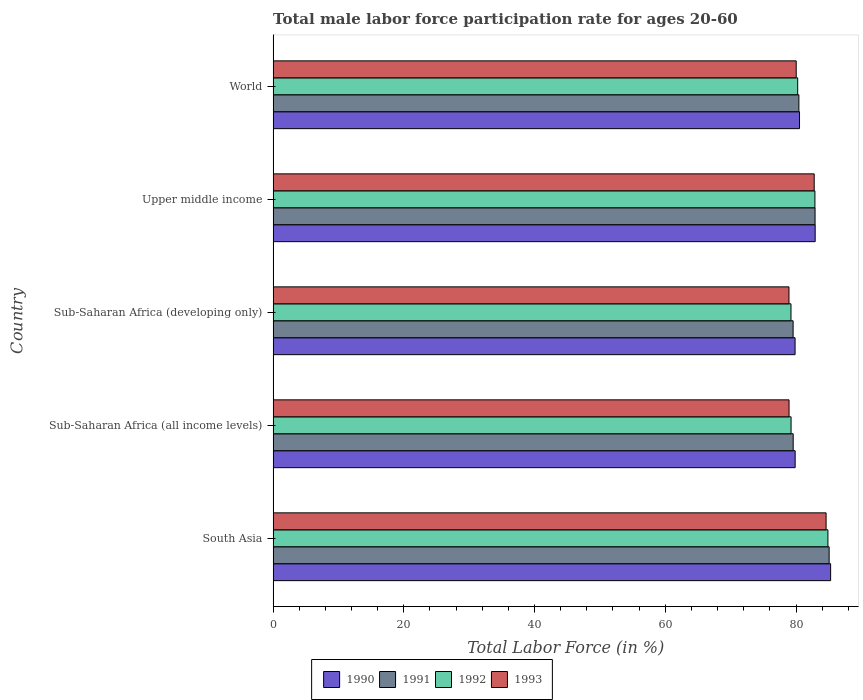Are the number of bars per tick equal to the number of legend labels?
Ensure brevity in your answer.  Yes. Are the number of bars on each tick of the Y-axis equal?
Make the answer very short. Yes. How many bars are there on the 1st tick from the top?
Ensure brevity in your answer.  4. What is the label of the 2nd group of bars from the top?
Keep it short and to the point. Upper middle income. In how many cases, is the number of bars for a given country not equal to the number of legend labels?
Offer a terse response. 0. What is the male labor force participation rate in 1990 in World?
Provide a short and direct response. 80.54. Across all countries, what is the maximum male labor force participation rate in 1992?
Provide a short and direct response. 84.88. Across all countries, what is the minimum male labor force participation rate in 1990?
Keep it short and to the point. 79.86. In which country was the male labor force participation rate in 1991 minimum?
Your answer should be compact. Sub-Saharan Africa (developing only). What is the total male labor force participation rate in 1991 in the graph?
Your answer should be very brief. 407.56. What is the difference between the male labor force participation rate in 1992 in Sub-Saharan Africa (all income levels) and that in Upper middle income?
Give a very brief answer. -3.65. What is the difference between the male labor force participation rate in 1993 in World and the male labor force participation rate in 1992 in Upper middle income?
Give a very brief answer. -2.86. What is the average male labor force participation rate in 1991 per country?
Ensure brevity in your answer.  81.51. What is the difference between the male labor force participation rate in 1990 and male labor force participation rate in 1993 in World?
Provide a short and direct response. 0.51. In how many countries, is the male labor force participation rate in 1992 greater than 24 %?
Offer a terse response. 5. What is the ratio of the male labor force participation rate in 1992 in South Asia to that in Sub-Saharan Africa (all income levels)?
Your response must be concise. 1.07. Is the male labor force participation rate in 1993 in Sub-Saharan Africa (developing only) less than that in World?
Give a very brief answer. Yes. What is the difference between the highest and the second highest male labor force participation rate in 1990?
Provide a short and direct response. 2.36. What is the difference between the highest and the lowest male labor force participation rate in 1992?
Keep it short and to the point. 5.65. In how many countries, is the male labor force participation rate in 1992 greater than the average male labor force participation rate in 1992 taken over all countries?
Give a very brief answer. 2. Is it the case that in every country, the sum of the male labor force participation rate in 1991 and male labor force participation rate in 1992 is greater than the sum of male labor force participation rate in 1990 and male labor force participation rate in 1993?
Your answer should be very brief. No. What does the 1st bar from the top in Sub-Saharan Africa (developing only) represents?
Your answer should be very brief. 1993. How many bars are there?
Make the answer very short. 20. What is the difference between two consecutive major ticks on the X-axis?
Your response must be concise. 20. Are the values on the major ticks of X-axis written in scientific E-notation?
Offer a very short reply. No. Does the graph contain grids?
Keep it short and to the point. No. Where does the legend appear in the graph?
Offer a very short reply. Bottom center. How many legend labels are there?
Your response must be concise. 4. What is the title of the graph?
Your response must be concise. Total male labor force participation rate for ages 20-60. Does "1979" appear as one of the legend labels in the graph?
Offer a terse response. No. What is the Total Labor Force (in %) of 1990 in South Asia?
Provide a succinct answer. 85.3. What is the Total Labor Force (in %) in 1991 in South Asia?
Make the answer very short. 85.07. What is the Total Labor Force (in %) in 1992 in South Asia?
Your response must be concise. 84.88. What is the Total Labor Force (in %) in 1993 in South Asia?
Your answer should be compact. 84.6. What is the Total Labor Force (in %) in 1990 in Sub-Saharan Africa (all income levels)?
Make the answer very short. 79.87. What is the Total Labor Force (in %) of 1991 in Sub-Saharan Africa (all income levels)?
Ensure brevity in your answer.  79.57. What is the Total Labor Force (in %) of 1992 in Sub-Saharan Africa (all income levels)?
Keep it short and to the point. 79.25. What is the Total Labor Force (in %) of 1993 in Sub-Saharan Africa (all income levels)?
Offer a terse response. 78.94. What is the Total Labor Force (in %) of 1990 in Sub-Saharan Africa (developing only)?
Give a very brief answer. 79.86. What is the Total Labor Force (in %) of 1991 in Sub-Saharan Africa (developing only)?
Your response must be concise. 79.56. What is the Total Labor Force (in %) in 1992 in Sub-Saharan Africa (developing only)?
Your response must be concise. 79.23. What is the Total Labor Force (in %) of 1993 in Sub-Saharan Africa (developing only)?
Keep it short and to the point. 78.93. What is the Total Labor Force (in %) of 1990 in Upper middle income?
Give a very brief answer. 82.93. What is the Total Labor Force (in %) of 1991 in Upper middle income?
Ensure brevity in your answer.  82.92. What is the Total Labor Force (in %) in 1992 in Upper middle income?
Offer a terse response. 82.89. What is the Total Labor Force (in %) of 1993 in Upper middle income?
Make the answer very short. 82.78. What is the Total Labor Force (in %) of 1990 in World?
Offer a terse response. 80.54. What is the Total Labor Force (in %) of 1991 in World?
Offer a very short reply. 80.44. What is the Total Labor Force (in %) in 1992 in World?
Keep it short and to the point. 80.26. What is the Total Labor Force (in %) in 1993 in World?
Keep it short and to the point. 80.03. Across all countries, what is the maximum Total Labor Force (in %) of 1990?
Ensure brevity in your answer.  85.3. Across all countries, what is the maximum Total Labor Force (in %) of 1991?
Your response must be concise. 85.07. Across all countries, what is the maximum Total Labor Force (in %) of 1992?
Your answer should be compact. 84.88. Across all countries, what is the maximum Total Labor Force (in %) in 1993?
Provide a short and direct response. 84.6. Across all countries, what is the minimum Total Labor Force (in %) of 1990?
Ensure brevity in your answer.  79.86. Across all countries, what is the minimum Total Labor Force (in %) in 1991?
Offer a very short reply. 79.56. Across all countries, what is the minimum Total Labor Force (in %) in 1992?
Offer a terse response. 79.23. Across all countries, what is the minimum Total Labor Force (in %) in 1993?
Make the answer very short. 78.93. What is the total Total Labor Force (in %) of 1990 in the graph?
Your response must be concise. 408.5. What is the total Total Labor Force (in %) in 1991 in the graph?
Make the answer very short. 407.56. What is the total Total Labor Force (in %) of 1992 in the graph?
Your answer should be compact. 406.52. What is the total Total Labor Force (in %) in 1993 in the graph?
Give a very brief answer. 405.28. What is the difference between the Total Labor Force (in %) in 1990 in South Asia and that in Sub-Saharan Africa (all income levels)?
Offer a terse response. 5.43. What is the difference between the Total Labor Force (in %) of 1991 in South Asia and that in Sub-Saharan Africa (all income levels)?
Your answer should be very brief. 5.5. What is the difference between the Total Labor Force (in %) in 1992 in South Asia and that in Sub-Saharan Africa (all income levels)?
Provide a succinct answer. 5.64. What is the difference between the Total Labor Force (in %) in 1993 in South Asia and that in Sub-Saharan Africa (all income levels)?
Provide a short and direct response. 5.67. What is the difference between the Total Labor Force (in %) in 1990 in South Asia and that in Sub-Saharan Africa (developing only)?
Your answer should be compact. 5.44. What is the difference between the Total Labor Force (in %) in 1991 in South Asia and that in Sub-Saharan Africa (developing only)?
Offer a terse response. 5.51. What is the difference between the Total Labor Force (in %) of 1992 in South Asia and that in Sub-Saharan Africa (developing only)?
Your response must be concise. 5.65. What is the difference between the Total Labor Force (in %) of 1993 in South Asia and that in Sub-Saharan Africa (developing only)?
Keep it short and to the point. 5.68. What is the difference between the Total Labor Force (in %) of 1990 in South Asia and that in Upper middle income?
Your answer should be compact. 2.36. What is the difference between the Total Labor Force (in %) in 1991 in South Asia and that in Upper middle income?
Give a very brief answer. 2.15. What is the difference between the Total Labor Force (in %) of 1992 in South Asia and that in Upper middle income?
Your answer should be very brief. 1.99. What is the difference between the Total Labor Force (in %) of 1993 in South Asia and that in Upper middle income?
Ensure brevity in your answer.  1.82. What is the difference between the Total Labor Force (in %) in 1990 in South Asia and that in World?
Provide a short and direct response. 4.76. What is the difference between the Total Labor Force (in %) of 1991 in South Asia and that in World?
Your response must be concise. 4.63. What is the difference between the Total Labor Force (in %) in 1992 in South Asia and that in World?
Provide a short and direct response. 4.63. What is the difference between the Total Labor Force (in %) of 1993 in South Asia and that in World?
Give a very brief answer. 4.57. What is the difference between the Total Labor Force (in %) in 1990 in Sub-Saharan Africa (all income levels) and that in Sub-Saharan Africa (developing only)?
Ensure brevity in your answer.  0.01. What is the difference between the Total Labor Force (in %) of 1991 in Sub-Saharan Africa (all income levels) and that in Sub-Saharan Africa (developing only)?
Keep it short and to the point. 0.01. What is the difference between the Total Labor Force (in %) in 1992 in Sub-Saharan Africa (all income levels) and that in Sub-Saharan Africa (developing only)?
Your answer should be compact. 0.01. What is the difference between the Total Labor Force (in %) in 1993 in Sub-Saharan Africa (all income levels) and that in Sub-Saharan Africa (developing only)?
Your answer should be very brief. 0.01. What is the difference between the Total Labor Force (in %) of 1990 in Sub-Saharan Africa (all income levels) and that in Upper middle income?
Give a very brief answer. -3.06. What is the difference between the Total Labor Force (in %) of 1991 in Sub-Saharan Africa (all income levels) and that in Upper middle income?
Your response must be concise. -3.35. What is the difference between the Total Labor Force (in %) of 1992 in Sub-Saharan Africa (all income levels) and that in Upper middle income?
Offer a very short reply. -3.65. What is the difference between the Total Labor Force (in %) of 1993 in Sub-Saharan Africa (all income levels) and that in Upper middle income?
Make the answer very short. -3.85. What is the difference between the Total Labor Force (in %) in 1990 in Sub-Saharan Africa (all income levels) and that in World?
Offer a terse response. -0.67. What is the difference between the Total Labor Force (in %) of 1991 in Sub-Saharan Africa (all income levels) and that in World?
Offer a terse response. -0.87. What is the difference between the Total Labor Force (in %) in 1992 in Sub-Saharan Africa (all income levels) and that in World?
Offer a terse response. -1.01. What is the difference between the Total Labor Force (in %) of 1993 in Sub-Saharan Africa (all income levels) and that in World?
Offer a very short reply. -1.09. What is the difference between the Total Labor Force (in %) in 1990 in Sub-Saharan Africa (developing only) and that in Upper middle income?
Your response must be concise. -3.07. What is the difference between the Total Labor Force (in %) in 1991 in Sub-Saharan Africa (developing only) and that in Upper middle income?
Offer a very short reply. -3.36. What is the difference between the Total Labor Force (in %) in 1992 in Sub-Saharan Africa (developing only) and that in Upper middle income?
Give a very brief answer. -3.66. What is the difference between the Total Labor Force (in %) in 1993 in Sub-Saharan Africa (developing only) and that in Upper middle income?
Your answer should be compact. -3.86. What is the difference between the Total Labor Force (in %) of 1990 in Sub-Saharan Africa (developing only) and that in World?
Ensure brevity in your answer.  -0.68. What is the difference between the Total Labor Force (in %) in 1991 in Sub-Saharan Africa (developing only) and that in World?
Your answer should be compact. -0.88. What is the difference between the Total Labor Force (in %) of 1992 in Sub-Saharan Africa (developing only) and that in World?
Offer a terse response. -1.02. What is the difference between the Total Labor Force (in %) of 1993 in Sub-Saharan Africa (developing only) and that in World?
Make the answer very short. -1.11. What is the difference between the Total Labor Force (in %) of 1990 in Upper middle income and that in World?
Provide a short and direct response. 2.4. What is the difference between the Total Labor Force (in %) of 1991 in Upper middle income and that in World?
Your answer should be compact. 2.48. What is the difference between the Total Labor Force (in %) of 1992 in Upper middle income and that in World?
Your answer should be compact. 2.64. What is the difference between the Total Labor Force (in %) in 1993 in Upper middle income and that in World?
Offer a terse response. 2.75. What is the difference between the Total Labor Force (in %) of 1990 in South Asia and the Total Labor Force (in %) of 1991 in Sub-Saharan Africa (all income levels)?
Offer a terse response. 5.73. What is the difference between the Total Labor Force (in %) of 1990 in South Asia and the Total Labor Force (in %) of 1992 in Sub-Saharan Africa (all income levels)?
Your answer should be very brief. 6.05. What is the difference between the Total Labor Force (in %) in 1990 in South Asia and the Total Labor Force (in %) in 1993 in Sub-Saharan Africa (all income levels)?
Your response must be concise. 6.36. What is the difference between the Total Labor Force (in %) in 1991 in South Asia and the Total Labor Force (in %) in 1992 in Sub-Saharan Africa (all income levels)?
Ensure brevity in your answer.  5.83. What is the difference between the Total Labor Force (in %) in 1991 in South Asia and the Total Labor Force (in %) in 1993 in Sub-Saharan Africa (all income levels)?
Keep it short and to the point. 6.13. What is the difference between the Total Labor Force (in %) of 1992 in South Asia and the Total Labor Force (in %) of 1993 in Sub-Saharan Africa (all income levels)?
Offer a terse response. 5.95. What is the difference between the Total Labor Force (in %) of 1990 in South Asia and the Total Labor Force (in %) of 1991 in Sub-Saharan Africa (developing only)?
Give a very brief answer. 5.74. What is the difference between the Total Labor Force (in %) in 1990 in South Asia and the Total Labor Force (in %) in 1992 in Sub-Saharan Africa (developing only)?
Provide a short and direct response. 6.06. What is the difference between the Total Labor Force (in %) in 1990 in South Asia and the Total Labor Force (in %) in 1993 in Sub-Saharan Africa (developing only)?
Your answer should be very brief. 6.37. What is the difference between the Total Labor Force (in %) in 1991 in South Asia and the Total Labor Force (in %) in 1992 in Sub-Saharan Africa (developing only)?
Give a very brief answer. 5.84. What is the difference between the Total Labor Force (in %) of 1991 in South Asia and the Total Labor Force (in %) of 1993 in Sub-Saharan Africa (developing only)?
Provide a succinct answer. 6.14. What is the difference between the Total Labor Force (in %) of 1992 in South Asia and the Total Labor Force (in %) of 1993 in Sub-Saharan Africa (developing only)?
Make the answer very short. 5.96. What is the difference between the Total Labor Force (in %) in 1990 in South Asia and the Total Labor Force (in %) in 1991 in Upper middle income?
Your response must be concise. 2.38. What is the difference between the Total Labor Force (in %) in 1990 in South Asia and the Total Labor Force (in %) in 1992 in Upper middle income?
Make the answer very short. 2.4. What is the difference between the Total Labor Force (in %) of 1990 in South Asia and the Total Labor Force (in %) of 1993 in Upper middle income?
Keep it short and to the point. 2.51. What is the difference between the Total Labor Force (in %) of 1991 in South Asia and the Total Labor Force (in %) of 1992 in Upper middle income?
Ensure brevity in your answer.  2.18. What is the difference between the Total Labor Force (in %) in 1991 in South Asia and the Total Labor Force (in %) in 1993 in Upper middle income?
Ensure brevity in your answer.  2.29. What is the difference between the Total Labor Force (in %) of 1992 in South Asia and the Total Labor Force (in %) of 1993 in Upper middle income?
Make the answer very short. 2.1. What is the difference between the Total Labor Force (in %) in 1990 in South Asia and the Total Labor Force (in %) in 1991 in World?
Your answer should be very brief. 4.86. What is the difference between the Total Labor Force (in %) in 1990 in South Asia and the Total Labor Force (in %) in 1992 in World?
Your response must be concise. 5.04. What is the difference between the Total Labor Force (in %) in 1990 in South Asia and the Total Labor Force (in %) in 1993 in World?
Your answer should be very brief. 5.27. What is the difference between the Total Labor Force (in %) in 1991 in South Asia and the Total Labor Force (in %) in 1992 in World?
Make the answer very short. 4.81. What is the difference between the Total Labor Force (in %) in 1991 in South Asia and the Total Labor Force (in %) in 1993 in World?
Provide a succinct answer. 5.04. What is the difference between the Total Labor Force (in %) of 1992 in South Asia and the Total Labor Force (in %) of 1993 in World?
Ensure brevity in your answer.  4.85. What is the difference between the Total Labor Force (in %) of 1990 in Sub-Saharan Africa (all income levels) and the Total Labor Force (in %) of 1991 in Sub-Saharan Africa (developing only)?
Your answer should be very brief. 0.31. What is the difference between the Total Labor Force (in %) in 1990 in Sub-Saharan Africa (all income levels) and the Total Labor Force (in %) in 1992 in Sub-Saharan Africa (developing only)?
Provide a short and direct response. 0.64. What is the difference between the Total Labor Force (in %) in 1990 in Sub-Saharan Africa (all income levels) and the Total Labor Force (in %) in 1993 in Sub-Saharan Africa (developing only)?
Keep it short and to the point. 0.95. What is the difference between the Total Labor Force (in %) in 1991 in Sub-Saharan Africa (all income levels) and the Total Labor Force (in %) in 1992 in Sub-Saharan Africa (developing only)?
Offer a very short reply. 0.34. What is the difference between the Total Labor Force (in %) of 1991 in Sub-Saharan Africa (all income levels) and the Total Labor Force (in %) of 1993 in Sub-Saharan Africa (developing only)?
Give a very brief answer. 0.64. What is the difference between the Total Labor Force (in %) of 1992 in Sub-Saharan Africa (all income levels) and the Total Labor Force (in %) of 1993 in Sub-Saharan Africa (developing only)?
Your answer should be compact. 0.32. What is the difference between the Total Labor Force (in %) in 1990 in Sub-Saharan Africa (all income levels) and the Total Labor Force (in %) in 1991 in Upper middle income?
Your response must be concise. -3.05. What is the difference between the Total Labor Force (in %) in 1990 in Sub-Saharan Africa (all income levels) and the Total Labor Force (in %) in 1992 in Upper middle income?
Ensure brevity in your answer.  -3.02. What is the difference between the Total Labor Force (in %) of 1990 in Sub-Saharan Africa (all income levels) and the Total Labor Force (in %) of 1993 in Upper middle income?
Your answer should be compact. -2.91. What is the difference between the Total Labor Force (in %) in 1991 in Sub-Saharan Africa (all income levels) and the Total Labor Force (in %) in 1992 in Upper middle income?
Provide a short and direct response. -3.32. What is the difference between the Total Labor Force (in %) of 1991 in Sub-Saharan Africa (all income levels) and the Total Labor Force (in %) of 1993 in Upper middle income?
Keep it short and to the point. -3.21. What is the difference between the Total Labor Force (in %) of 1992 in Sub-Saharan Africa (all income levels) and the Total Labor Force (in %) of 1993 in Upper middle income?
Give a very brief answer. -3.54. What is the difference between the Total Labor Force (in %) in 1990 in Sub-Saharan Africa (all income levels) and the Total Labor Force (in %) in 1991 in World?
Keep it short and to the point. -0.57. What is the difference between the Total Labor Force (in %) in 1990 in Sub-Saharan Africa (all income levels) and the Total Labor Force (in %) in 1992 in World?
Provide a short and direct response. -0.39. What is the difference between the Total Labor Force (in %) in 1990 in Sub-Saharan Africa (all income levels) and the Total Labor Force (in %) in 1993 in World?
Your answer should be compact. -0.16. What is the difference between the Total Labor Force (in %) in 1991 in Sub-Saharan Africa (all income levels) and the Total Labor Force (in %) in 1992 in World?
Offer a terse response. -0.69. What is the difference between the Total Labor Force (in %) of 1991 in Sub-Saharan Africa (all income levels) and the Total Labor Force (in %) of 1993 in World?
Your answer should be compact. -0.46. What is the difference between the Total Labor Force (in %) in 1992 in Sub-Saharan Africa (all income levels) and the Total Labor Force (in %) in 1993 in World?
Ensure brevity in your answer.  -0.79. What is the difference between the Total Labor Force (in %) in 1990 in Sub-Saharan Africa (developing only) and the Total Labor Force (in %) in 1991 in Upper middle income?
Provide a succinct answer. -3.06. What is the difference between the Total Labor Force (in %) of 1990 in Sub-Saharan Africa (developing only) and the Total Labor Force (in %) of 1992 in Upper middle income?
Keep it short and to the point. -3.03. What is the difference between the Total Labor Force (in %) in 1990 in Sub-Saharan Africa (developing only) and the Total Labor Force (in %) in 1993 in Upper middle income?
Make the answer very short. -2.92. What is the difference between the Total Labor Force (in %) in 1991 in Sub-Saharan Africa (developing only) and the Total Labor Force (in %) in 1992 in Upper middle income?
Offer a terse response. -3.34. What is the difference between the Total Labor Force (in %) of 1991 in Sub-Saharan Africa (developing only) and the Total Labor Force (in %) of 1993 in Upper middle income?
Your answer should be very brief. -3.23. What is the difference between the Total Labor Force (in %) of 1992 in Sub-Saharan Africa (developing only) and the Total Labor Force (in %) of 1993 in Upper middle income?
Ensure brevity in your answer.  -3.55. What is the difference between the Total Labor Force (in %) in 1990 in Sub-Saharan Africa (developing only) and the Total Labor Force (in %) in 1991 in World?
Your answer should be very brief. -0.58. What is the difference between the Total Labor Force (in %) of 1990 in Sub-Saharan Africa (developing only) and the Total Labor Force (in %) of 1992 in World?
Provide a succinct answer. -0.4. What is the difference between the Total Labor Force (in %) of 1990 in Sub-Saharan Africa (developing only) and the Total Labor Force (in %) of 1993 in World?
Ensure brevity in your answer.  -0.17. What is the difference between the Total Labor Force (in %) in 1991 in Sub-Saharan Africa (developing only) and the Total Labor Force (in %) in 1992 in World?
Your answer should be compact. -0.7. What is the difference between the Total Labor Force (in %) in 1991 in Sub-Saharan Africa (developing only) and the Total Labor Force (in %) in 1993 in World?
Keep it short and to the point. -0.47. What is the difference between the Total Labor Force (in %) of 1992 in Sub-Saharan Africa (developing only) and the Total Labor Force (in %) of 1993 in World?
Your answer should be very brief. -0.8. What is the difference between the Total Labor Force (in %) of 1990 in Upper middle income and the Total Labor Force (in %) of 1991 in World?
Provide a short and direct response. 2.49. What is the difference between the Total Labor Force (in %) of 1990 in Upper middle income and the Total Labor Force (in %) of 1992 in World?
Provide a succinct answer. 2.68. What is the difference between the Total Labor Force (in %) in 1990 in Upper middle income and the Total Labor Force (in %) in 1993 in World?
Keep it short and to the point. 2.9. What is the difference between the Total Labor Force (in %) of 1991 in Upper middle income and the Total Labor Force (in %) of 1992 in World?
Give a very brief answer. 2.66. What is the difference between the Total Labor Force (in %) in 1991 in Upper middle income and the Total Labor Force (in %) in 1993 in World?
Offer a terse response. 2.89. What is the difference between the Total Labor Force (in %) in 1992 in Upper middle income and the Total Labor Force (in %) in 1993 in World?
Ensure brevity in your answer.  2.86. What is the average Total Labor Force (in %) in 1990 per country?
Your answer should be compact. 81.7. What is the average Total Labor Force (in %) of 1991 per country?
Provide a short and direct response. 81.51. What is the average Total Labor Force (in %) of 1992 per country?
Ensure brevity in your answer.  81.3. What is the average Total Labor Force (in %) in 1993 per country?
Provide a succinct answer. 81.06. What is the difference between the Total Labor Force (in %) of 1990 and Total Labor Force (in %) of 1991 in South Asia?
Give a very brief answer. 0.23. What is the difference between the Total Labor Force (in %) of 1990 and Total Labor Force (in %) of 1992 in South Asia?
Provide a short and direct response. 0.41. What is the difference between the Total Labor Force (in %) in 1990 and Total Labor Force (in %) in 1993 in South Asia?
Keep it short and to the point. 0.69. What is the difference between the Total Labor Force (in %) of 1991 and Total Labor Force (in %) of 1992 in South Asia?
Make the answer very short. 0.19. What is the difference between the Total Labor Force (in %) of 1991 and Total Labor Force (in %) of 1993 in South Asia?
Your answer should be very brief. 0.47. What is the difference between the Total Labor Force (in %) of 1992 and Total Labor Force (in %) of 1993 in South Asia?
Make the answer very short. 0.28. What is the difference between the Total Labor Force (in %) in 1990 and Total Labor Force (in %) in 1991 in Sub-Saharan Africa (all income levels)?
Your answer should be very brief. 0.3. What is the difference between the Total Labor Force (in %) of 1990 and Total Labor Force (in %) of 1992 in Sub-Saharan Africa (all income levels)?
Make the answer very short. 0.63. What is the difference between the Total Labor Force (in %) of 1990 and Total Labor Force (in %) of 1993 in Sub-Saharan Africa (all income levels)?
Ensure brevity in your answer.  0.93. What is the difference between the Total Labor Force (in %) in 1991 and Total Labor Force (in %) in 1992 in Sub-Saharan Africa (all income levels)?
Make the answer very short. 0.32. What is the difference between the Total Labor Force (in %) in 1991 and Total Labor Force (in %) in 1993 in Sub-Saharan Africa (all income levels)?
Offer a terse response. 0.63. What is the difference between the Total Labor Force (in %) in 1992 and Total Labor Force (in %) in 1993 in Sub-Saharan Africa (all income levels)?
Your response must be concise. 0.31. What is the difference between the Total Labor Force (in %) of 1990 and Total Labor Force (in %) of 1991 in Sub-Saharan Africa (developing only)?
Ensure brevity in your answer.  0.3. What is the difference between the Total Labor Force (in %) in 1990 and Total Labor Force (in %) in 1992 in Sub-Saharan Africa (developing only)?
Make the answer very short. 0.63. What is the difference between the Total Labor Force (in %) of 1990 and Total Labor Force (in %) of 1993 in Sub-Saharan Africa (developing only)?
Keep it short and to the point. 0.93. What is the difference between the Total Labor Force (in %) of 1991 and Total Labor Force (in %) of 1992 in Sub-Saharan Africa (developing only)?
Give a very brief answer. 0.33. What is the difference between the Total Labor Force (in %) in 1991 and Total Labor Force (in %) in 1993 in Sub-Saharan Africa (developing only)?
Your answer should be compact. 0.63. What is the difference between the Total Labor Force (in %) in 1992 and Total Labor Force (in %) in 1993 in Sub-Saharan Africa (developing only)?
Your response must be concise. 0.31. What is the difference between the Total Labor Force (in %) in 1990 and Total Labor Force (in %) in 1991 in Upper middle income?
Ensure brevity in your answer.  0.02. What is the difference between the Total Labor Force (in %) in 1990 and Total Labor Force (in %) in 1992 in Upper middle income?
Provide a short and direct response. 0.04. What is the difference between the Total Labor Force (in %) of 1990 and Total Labor Force (in %) of 1993 in Upper middle income?
Make the answer very short. 0.15. What is the difference between the Total Labor Force (in %) of 1991 and Total Labor Force (in %) of 1992 in Upper middle income?
Provide a short and direct response. 0.02. What is the difference between the Total Labor Force (in %) in 1991 and Total Labor Force (in %) in 1993 in Upper middle income?
Offer a very short reply. 0.13. What is the difference between the Total Labor Force (in %) in 1992 and Total Labor Force (in %) in 1993 in Upper middle income?
Your answer should be compact. 0.11. What is the difference between the Total Labor Force (in %) in 1990 and Total Labor Force (in %) in 1991 in World?
Your answer should be compact. 0.1. What is the difference between the Total Labor Force (in %) in 1990 and Total Labor Force (in %) in 1992 in World?
Provide a succinct answer. 0.28. What is the difference between the Total Labor Force (in %) in 1990 and Total Labor Force (in %) in 1993 in World?
Keep it short and to the point. 0.51. What is the difference between the Total Labor Force (in %) in 1991 and Total Labor Force (in %) in 1992 in World?
Make the answer very short. 0.18. What is the difference between the Total Labor Force (in %) of 1991 and Total Labor Force (in %) of 1993 in World?
Ensure brevity in your answer.  0.41. What is the difference between the Total Labor Force (in %) of 1992 and Total Labor Force (in %) of 1993 in World?
Your answer should be very brief. 0.23. What is the ratio of the Total Labor Force (in %) of 1990 in South Asia to that in Sub-Saharan Africa (all income levels)?
Your answer should be very brief. 1.07. What is the ratio of the Total Labor Force (in %) of 1991 in South Asia to that in Sub-Saharan Africa (all income levels)?
Offer a very short reply. 1.07. What is the ratio of the Total Labor Force (in %) of 1992 in South Asia to that in Sub-Saharan Africa (all income levels)?
Provide a short and direct response. 1.07. What is the ratio of the Total Labor Force (in %) of 1993 in South Asia to that in Sub-Saharan Africa (all income levels)?
Give a very brief answer. 1.07. What is the ratio of the Total Labor Force (in %) of 1990 in South Asia to that in Sub-Saharan Africa (developing only)?
Your response must be concise. 1.07. What is the ratio of the Total Labor Force (in %) of 1991 in South Asia to that in Sub-Saharan Africa (developing only)?
Provide a succinct answer. 1.07. What is the ratio of the Total Labor Force (in %) of 1992 in South Asia to that in Sub-Saharan Africa (developing only)?
Make the answer very short. 1.07. What is the ratio of the Total Labor Force (in %) of 1993 in South Asia to that in Sub-Saharan Africa (developing only)?
Make the answer very short. 1.07. What is the ratio of the Total Labor Force (in %) of 1990 in South Asia to that in Upper middle income?
Ensure brevity in your answer.  1.03. What is the ratio of the Total Labor Force (in %) of 1990 in South Asia to that in World?
Offer a very short reply. 1.06. What is the ratio of the Total Labor Force (in %) in 1991 in South Asia to that in World?
Offer a terse response. 1.06. What is the ratio of the Total Labor Force (in %) in 1992 in South Asia to that in World?
Your answer should be compact. 1.06. What is the ratio of the Total Labor Force (in %) of 1993 in South Asia to that in World?
Keep it short and to the point. 1.06. What is the ratio of the Total Labor Force (in %) in 1990 in Sub-Saharan Africa (all income levels) to that in Sub-Saharan Africa (developing only)?
Offer a terse response. 1. What is the ratio of the Total Labor Force (in %) of 1991 in Sub-Saharan Africa (all income levels) to that in Sub-Saharan Africa (developing only)?
Ensure brevity in your answer.  1. What is the ratio of the Total Labor Force (in %) in 1990 in Sub-Saharan Africa (all income levels) to that in Upper middle income?
Make the answer very short. 0.96. What is the ratio of the Total Labor Force (in %) of 1991 in Sub-Saharan Africa (all income levels) to that in Upper middle income?
Offer a terse response. 0.96. What is the ratio of the Total Labor Force (in %) of 1992 in Sub-Saharan Africa (all income levels) to that in Upper middle income?
Provide a succinct answer. 0.96. What is the ratio of the Total Labor Force (in %) in 1993 in Sub-Saharan Africa (all income levels) to that in Upper middle income?
Offer a very short reply. 0.95. What is the ratio of the Total Labor Force (in %) in 1991 in Sub-Saharan Africa (all income levels) to that in World?
Make the answer very short. 0.99. What is the ratio of the Total Labor Force (in %) in 1992 in Sub-Saharan Africa (all income levels) to that in World?
Keep it short and to the point. 0.99. What is the ratio of the Total Labor Force (in %) in 1993 in Sub-Saharan Africa (all income levels) to that in World?
Your answer should be compact. 0.99. What is the ratio of the Total Labor Force (in %) in 1990 in Sub-Saharan Africa (developing only) to that in Upper middle income?
Your answer should be compact. 0.96. What is the ratio of the Total Labor Force (in %) in 1991 in Sub-Saharan Africa (developing only) to that in Upper middle income?
Your response must be concise. 0.96. What is the ratio of the Total Labor Force (in %) of 1992 in Sub-Saharan Africa (developing only) to that in Upper middle income?
Provide a succinct answer. 0.96. What is the ratio of the Total Labor Force (in %) of 1993 in Sub-Saharan Africa (developing only) to that in Upper middle income?
Ensure brevity in your answer.  0.95. What is the ratio of the Total Labor Force (in %) of 1991 in Sub-Saharan Africa (developing only) to that in World?
Your response must be concise. 0.99. What is the ratio of the Total Labor Force (in %) of 1992 in Sub-Saharan Africa (developing only) to that in World?
Provide a succinct answer. 0.99. What is the ratio of the Total Labor Force (in %) of 1993 in Sub-Saharan Africa (developing only) to that in World?
Offer a very short reply. 0.99. What is the ratio of the Total Labor Force (in %) of 1990 in Upper middle income to that in World?
Keep it short and to the point. 1.03. What is the ratio of the Total Labor Force (in %) of 1991 in Upper middle income to that in World?
Provide a succinct answer. 1.03. What is the ratio of the Total Labor Force (in %) of 1992 in Upper middle income to that in World?
Provide a succinct answer. 1.03. What is the ratio of the Total Labor Force (in %) of 1993 in Upper middle income to that in World?
Offer a very short reply. 1.03. What is the difference between the highest and the second highest Total Labor Force (in %) in 1990?
Your answer should be very brief. 2.36. What is the difference between the highest and the second highest Total Labor Force (in %) of 1991?
Give a very brief answer. 2.15. What is the difference between the highest and the second highest Total Labor Force (in %) in 1992?
Provide a short and direct response. 1.99. What is the difference between the highest and the second highest Total Labor Force (in %) in 1993?
Make the answer very short. 1.82. What is the difference between the highest and the lowest Total Labor Force (in %) in 1990?
Keep it short and to the point. 5.44. What is the difference between the highest and the lowest Total Labor Force (in %) in 1991?
Ensure brevity in your answer.  5.51. What is the difference between the highest and the lowest Total Labor Force (in %) of 1992?
Ensure brevity in your answer.  5.65. What is the difference between the highest and the lowest Total Labor Force (in %) in 1993?
Provide a succinct answer. 5.68. 